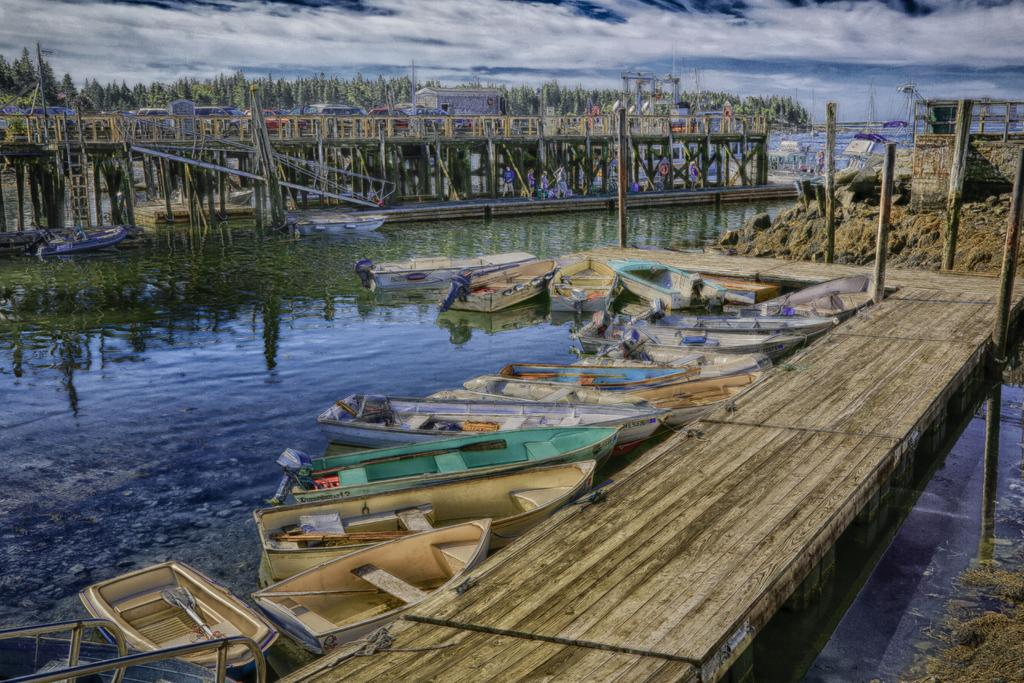What can be seen at the bottom of the image? At the bottom of the image, there are boats, a bridge, sticks, and water. What is located in the middle of the image? In the middle of the image, there are boats, a bridge, houses, trees, sky, and clouds. Can you describe the bridge in the image? The bridge is visible at both the bottom and the middle of the image. What type of vegetation is present in the image? Trees are present in the middle of the image. What part of the natural environment is visible in the image? Sky and clouds are visible in the middle of the image. What type of disease is affecting the trees in the image? There is no indication of any disease affecting the trees in the image; they appear healthy. How much honey can be seen dripping from the clouds in the image? There is no honey present in the image, as clouds are made of water vapor and do not contain honey. 